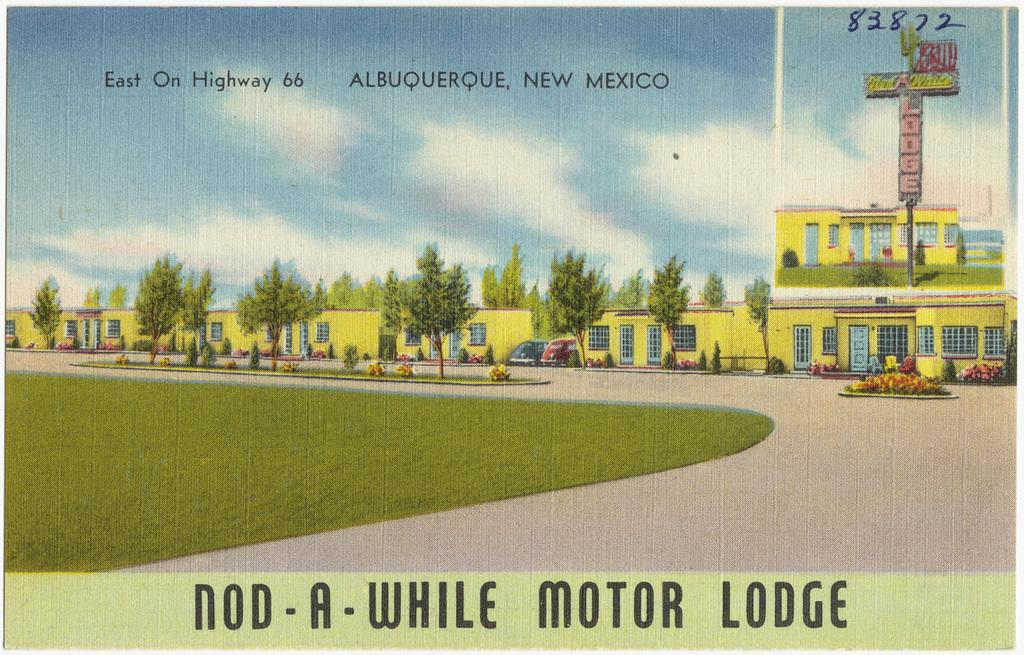<image>
Relay a brief, clear account of the picture shown. An old style postcard for a motor lodge. 